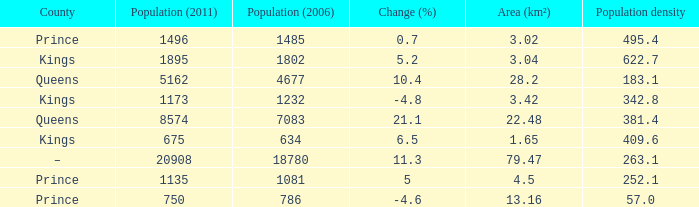What is the Population density that has a Change (%) higher than 10.4, and a Population (2011) less than 8574, in the County of Queens? None. 